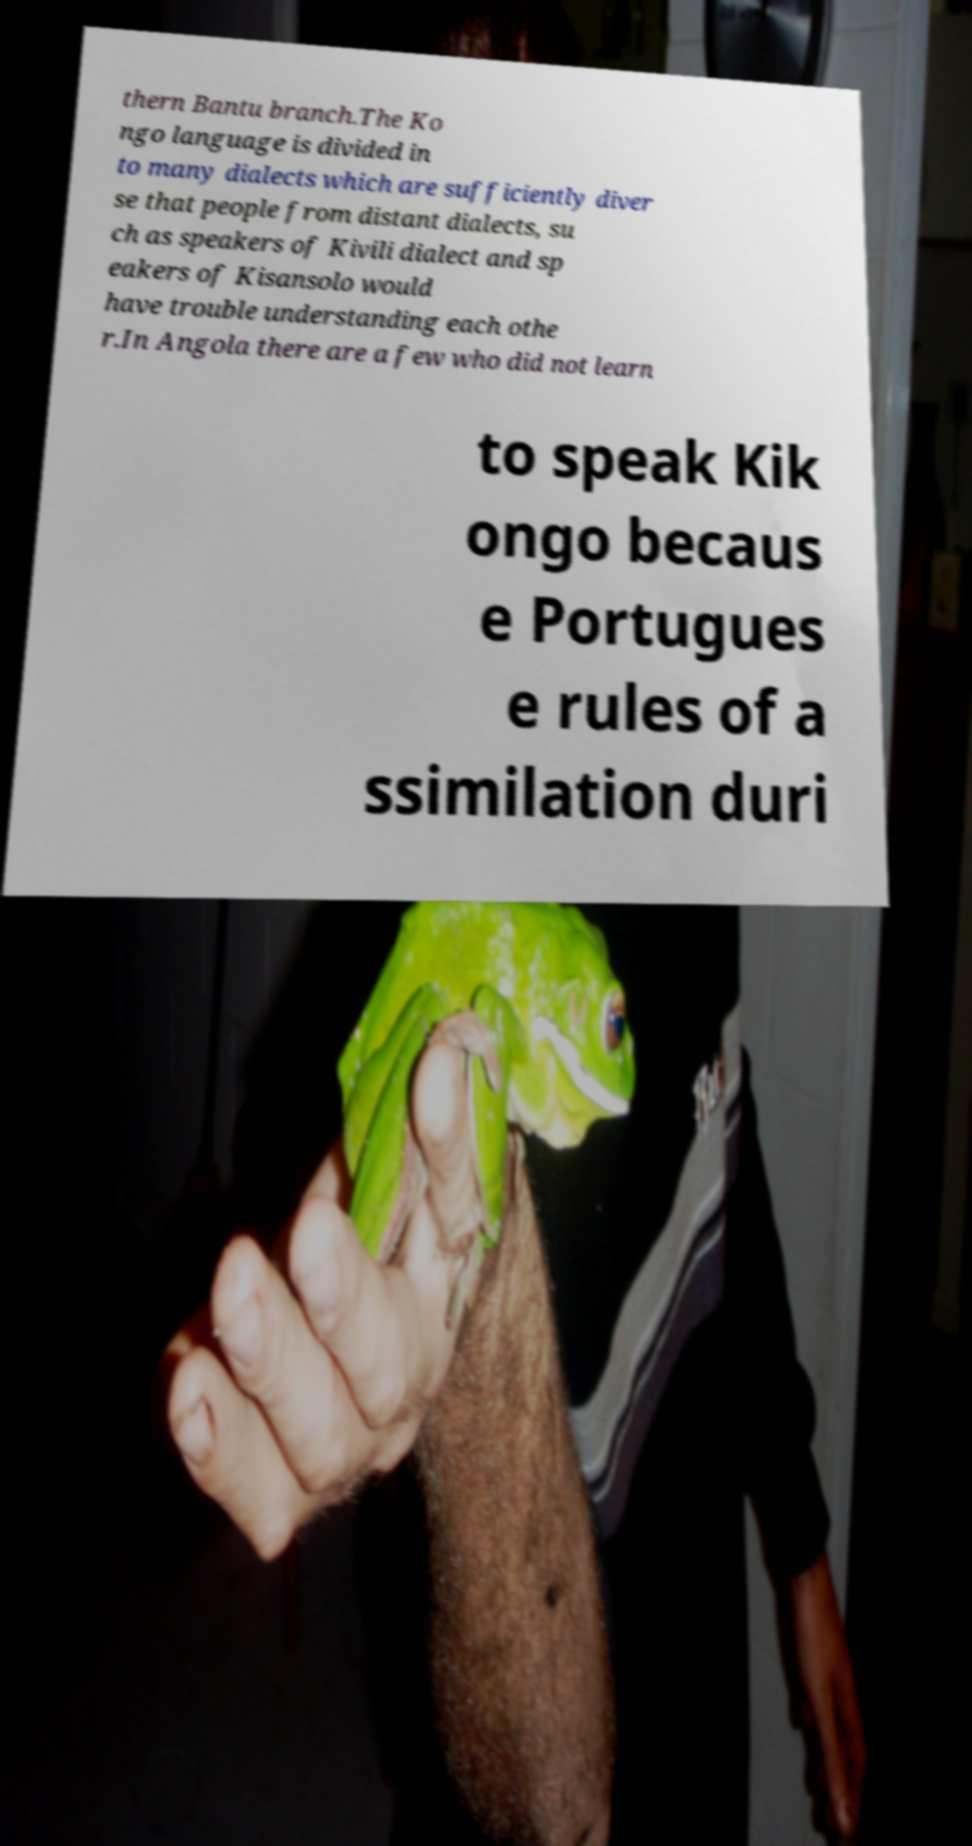What messages or text are displayed in this image? I need them in a readable, typed format. thern Bantu branch.The Ko ngo language is divided in to many dialects which are sufficiently diver se that people from distant dialects, su ch as speakers of Kivili dialect and sp eakers of Kisansolo would have trouble understanding each othe r.In Angola there are a few who did not learn to speak Kik ongo becaus e Portugues e rules of a ssimilation duri 